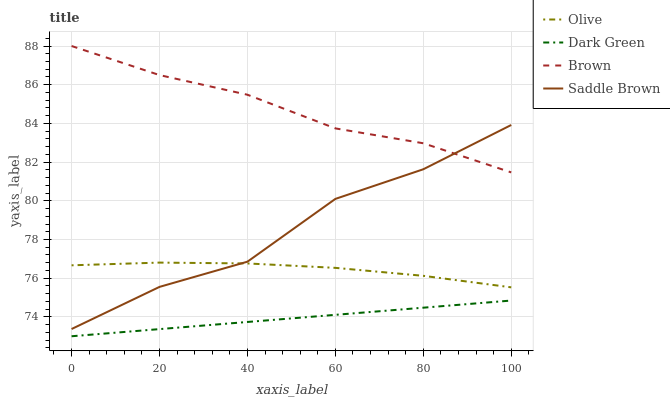Does Dark Green have the minimum area under the curve?
Answer yes or no. Yes. Does Brown have the maximum area under the curve?
Answer yes or no. Yes. Does Saddle Brown have the minimum area under the curve?
Answer yes or no. No. Does Saddle Brown have the maximum area under the curve?
Answer yes or no. No. Is Dark Green the smoothest?
Answer yes or no. Yes. Is Saddle Brown the roughest?
Answer yes or no. Yes. Is Brown the smoothest?
Answer yes or no. No. Is Brown the roughest?
Answer yes or no. No. Does Dark Green have the lowest value?
Answer yes or no. Yes. Does Saddle Brown have the lowest value?
Answer yes or no. No. Does Brown have the highest value?
Answer yes or no. Yes. Does Saddle Brown have the highest value?
Answer yes or no. No. Is Dark Green less than Olive?
Answer yes or no. Yes. Is Brown greater than Olive?
Answer yes or no. Yes. Does Saddle Brown intersect Brown?
Answer yes or no. Yes. Is Saddle Brown less than Brown?
Answer yes or no. No. Is Saddle Brown greater than Brown?
Answer yes or no. No. Does Dark Green intersect Olive?
Answer yes or no. No. 